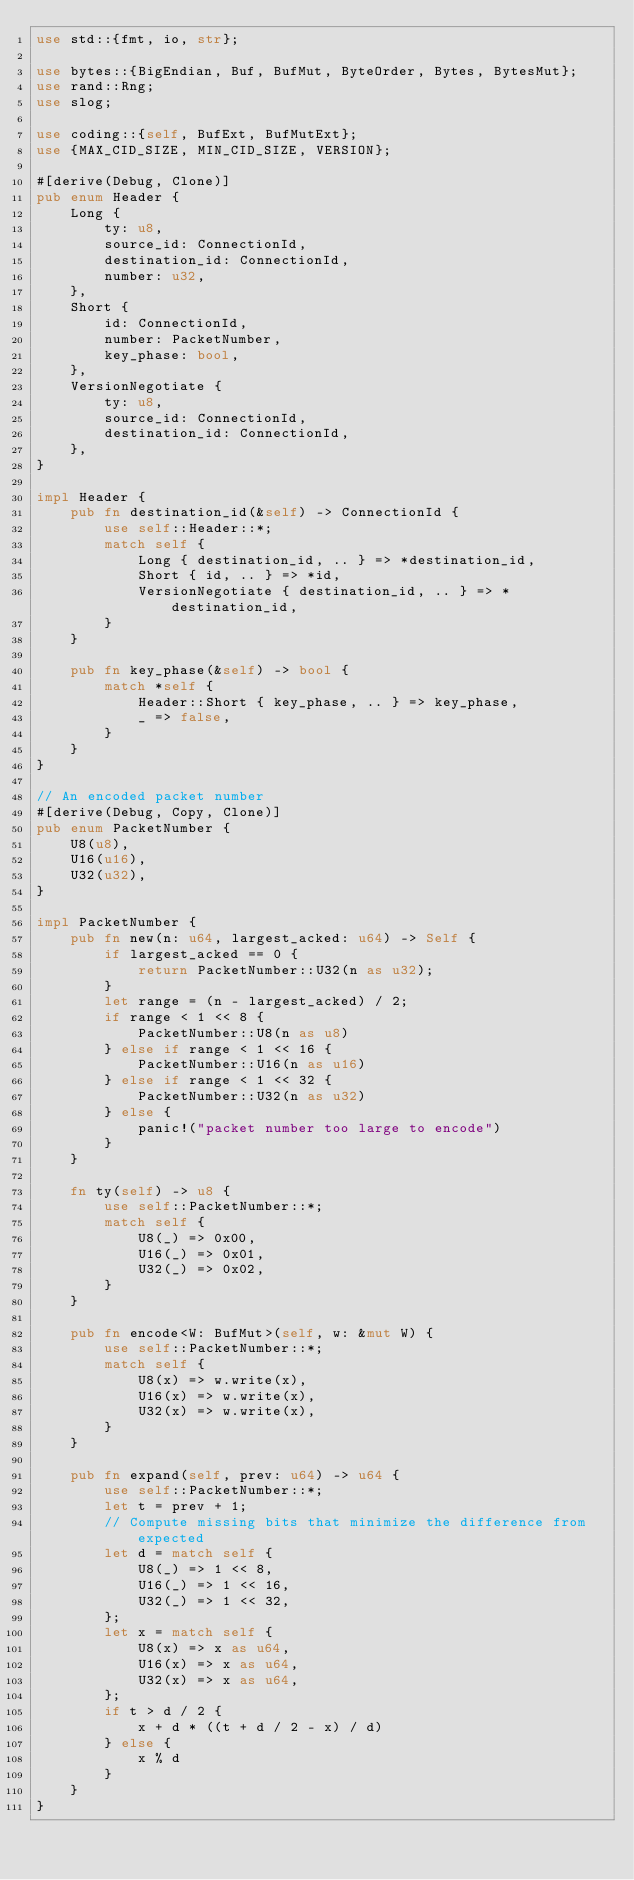Convert code to text. <code><loc_0><loc_0><loc_500><loc_500><_Rust_>use std::{fmt, io, str};

use bytes::{BigEndian, Buf, BufMut, ByteOrder, Bytes, BytesMut};
use rand::Rng;
use slog;

use coding::{self, BufExt, BufMutExt};
use {MAX_CID_SIZE, MIN_CID_SIZE, VERSION};

#[derive(Debug, Clone)]
pub enum Header {
    Long {
        ty: u8,
        source_id: ConnectionId,
        destination_id: ConnectionId,
        number: u32,
    },
    Short {
        id: ConnectionId,
        number: PacketNumber,
        key_phase: bool,
    },
    VersionNegotiate {
        ty: u8,
        source_id: ConnectionId,
        destination_id: ConnectionId,
    },
}

impl Header {
    pub fn destination_id(&self) -> ConnectionId {
        use self::Header::*;
        match self {
            Long { destination_id, .. } => *destination_id,
            Short { id, .. } => *id,
            VersionNegotiate { destination_id, .. } => *destination_id,
        }
    }

    pub fn key_phase(&self) -> bool {
        match *self {
            Header::Short { key_phase, .. } => key_phase,
            _ => false,
        }
    }
}

// An encoded packet number
#[derive(Debug, Copy, Clone)]
pub enum PacketNumber {
    U8(u8),
    U16(u16),
    U32(u32),
}

impl PacketNumber {
    pub fn new(n: u64, largest_acked: u64) -> Self {
        if largest_acked == 0 {
            return PacketNumber::U32(n as u32);
        }
        let range = (n - largest_acked) / 2;
        if range < 1 << 8 {
            PacketNumber::U8(n as u8)
        } else if range < 1 << 16 {
            PacketNumber::U16(n as u16)
        } else if range < 1 << 32 {
            PacketNumber::U32(n as u32)
        } else {
            panic!("packet number too large to encode")
        }
    }

    fn ty(self) -> u8 {
        use self::PacketNumber::*;
        match self {
            U8(_) => 0x00,
            U16(_) => 0x01,
            U32(_) => 0x02,
        }
    }

    pub fn encode<W: BufMut>(self, w: &mut W) {
        use self::PacketNumber::*;
        match self {
            U8(x) => w.write(x),
            U16(x) => w.write(x),
            U32(x) => w.write(x),
        }
    }

    pub fn expand(self, prev: u64) -> u64 {
        use self::PacketNumber::*;
        let t = prev + 1;
        // Compute missing bits that minimize the difference from expected
        let d = match self {
            U8(_) => 1 << 8,
            U16(_) => 1 << 16,
            U32(_) => 1 << 32,
        };
        let x = match self {
            U8(x) => x as u64,
            U16(x) => x as u64,
            U32(x) => x as u64,
        };
        if t > d / 2 {
            x + d * ((t + d / 2 - x) / d)
        } else {
            x % d
        }
    }
}
</code> 